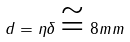<formula> <loc_0><loc_0><loc_500><loc_500>d = \eta \delta \cong 8 m m</formula> 